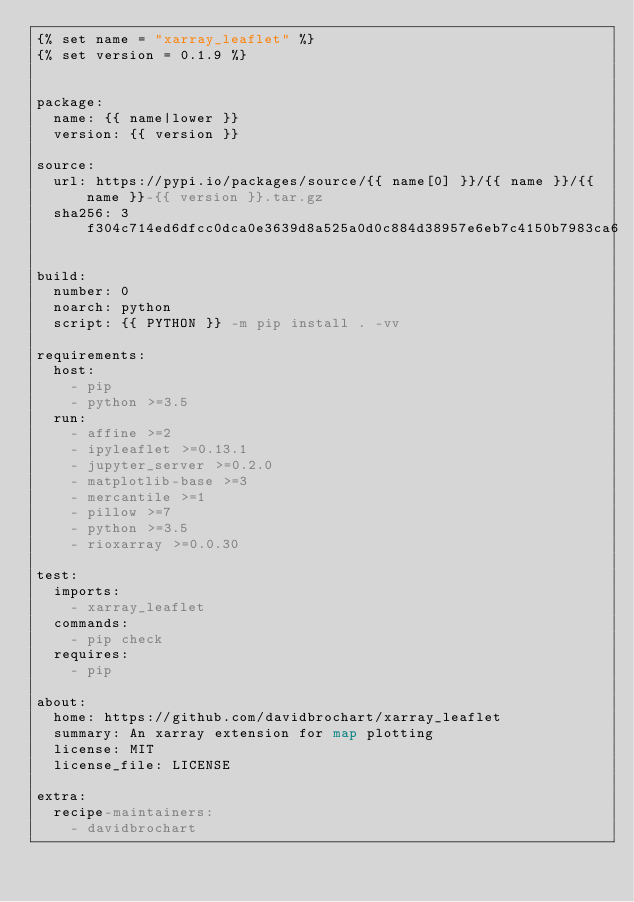<code> <loc_0><loc_0><loc_500><loc_500><_YAML_>{% set name = "xarray_leaflet" %}
{% set version = 0.1.9 %}


package:
  name: {{ name|lower }}
  version: {{ version }}

source:
  url: https://pypi.io/packages/source/{{ name[0] }}/{{ name }}/{{ name }}-{{ version }}.tar.gz
  sha256: 3f304c714ed6dfcc0dca0e3639d8a525a0d0c884d38957e6eb7c4150b7983ca6

build:
  number: 0
  noarch: python
  script: {{ PYTHON }} -m pip install . -vv

requirements:
  host:
    - pip
    - python >=3.5
  run:
    - affine >=2
    - ipyleaflet >=0.13.1
    - jupyter_server >=0.2.0
    - matplotlib-base >=3
    - mercantile >=1
    - pillow >=7
    - python >=3.5
    - rioxarray >=0.0.30

test:
  imports:
    - xarray_leaflet
  commands:
    - pip check
  requires:
    - pip

about:
  home: https://github.com/davidbrochart/xarray_leaflet
  summary: An xarray extension for map plotting
  license: MIT
  license_file: LICENSE

extra:
  recipe-maintainers:
    - davidbrochart
</code> 